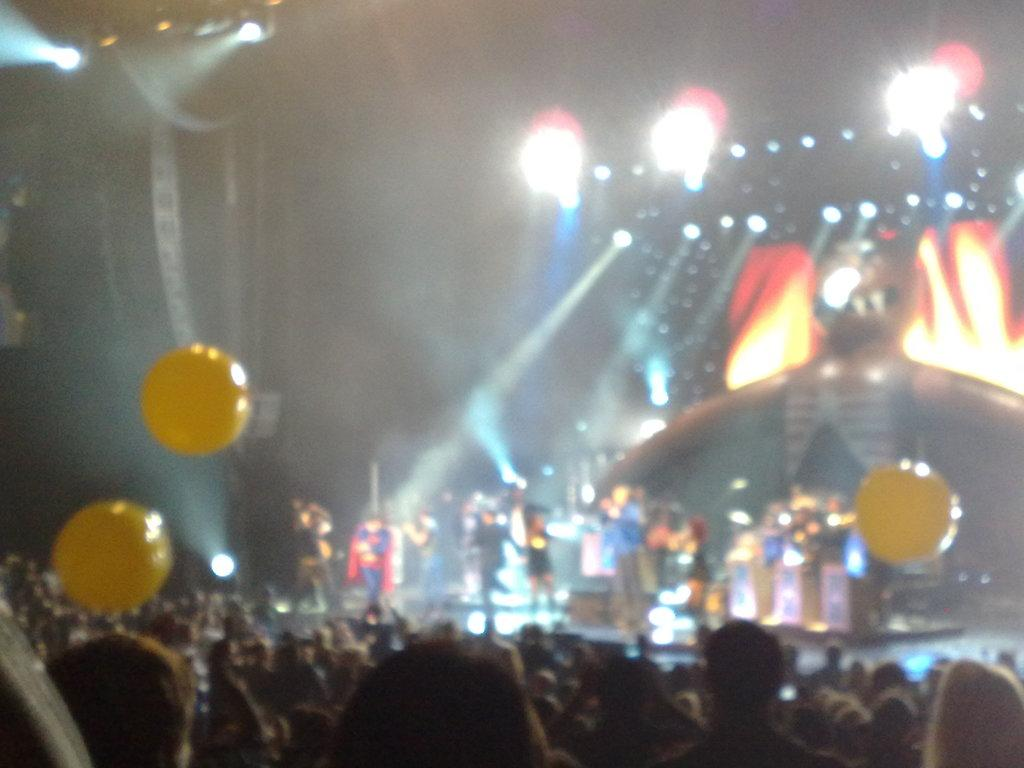Who or what can be seen in the image? There are people in the image. What else is visible in the image besides the people? There are lights and balloons present in the image. What type of coach is guiding the people on their voyage in the image? There is no coach or voyage depicted in the image; it only features people, lights, and balloons. 